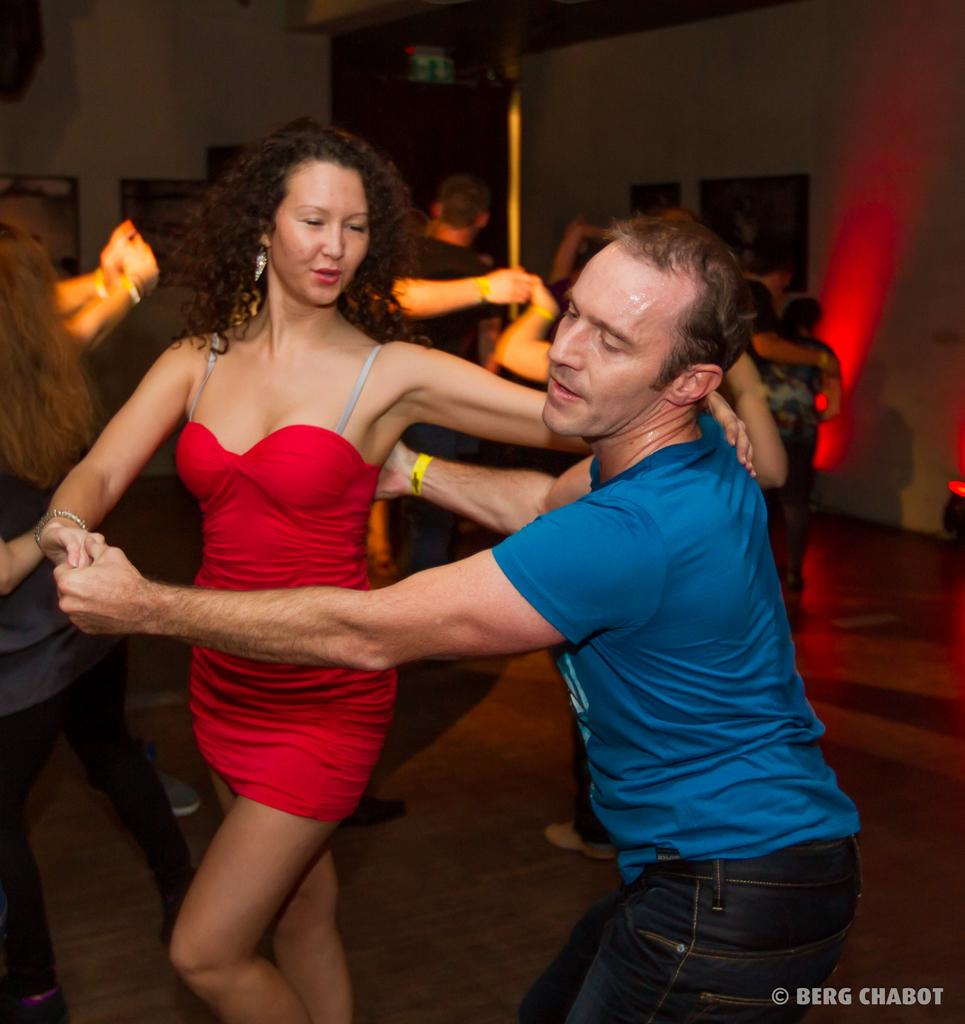What are the people in the image doing? The people in the image are dancing in the center of the image. What can be seen in the background of the image? There is a wall in the background of the image. What is the color of the throat in the image? There is no mention of a throat in the image, as it features people dancing in the center and a wall in the background. 